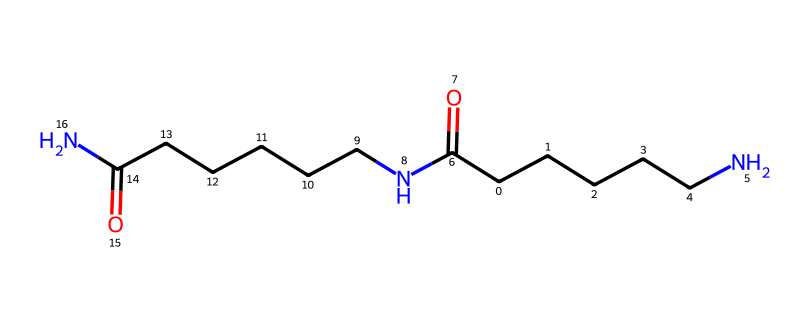What is the total number of carbon atoms in the structure? By analyzing the SMILES notation, we can identify each carbon (C) present. Breaking down the structure, we can count a total of 12 carbon atoms.
Answer: 12 How many nitrogen atoms are present in the chemical structure? The SMILES representation includes two 'N' symbols, which indicate the presence of two nitrogen atoms in the structure.
Answer: 2 What type of polymer is represented by this chemical structure? The chemical structure is indicative of a polyamide due to the repeating amide (–C(=O)N–) units that connect the carbon chains.
Answer: polyamide What functional groups can be identified in the nylon-6,6 structure? The prominent functional groups in this structure are the amide groups (-C(=O)N-), which occur twice, indicating the presence of amide linkages in the polymer backbone.
Answer: amide How many repeating units are likely in this polymer? The SMILES notation suggests that this polymer is composed of two repeating units of the amide chain, as derived from the distinct recurrent segments indicated in the structure.
Answer: 2 What property is linked to the presence of the long carbon chains in this polymer? The long carbon chains contribute to the hydrophobic character and overall strength of the polymer, which influences properties like tensile strength and durability.
Answer: hydrophobic 